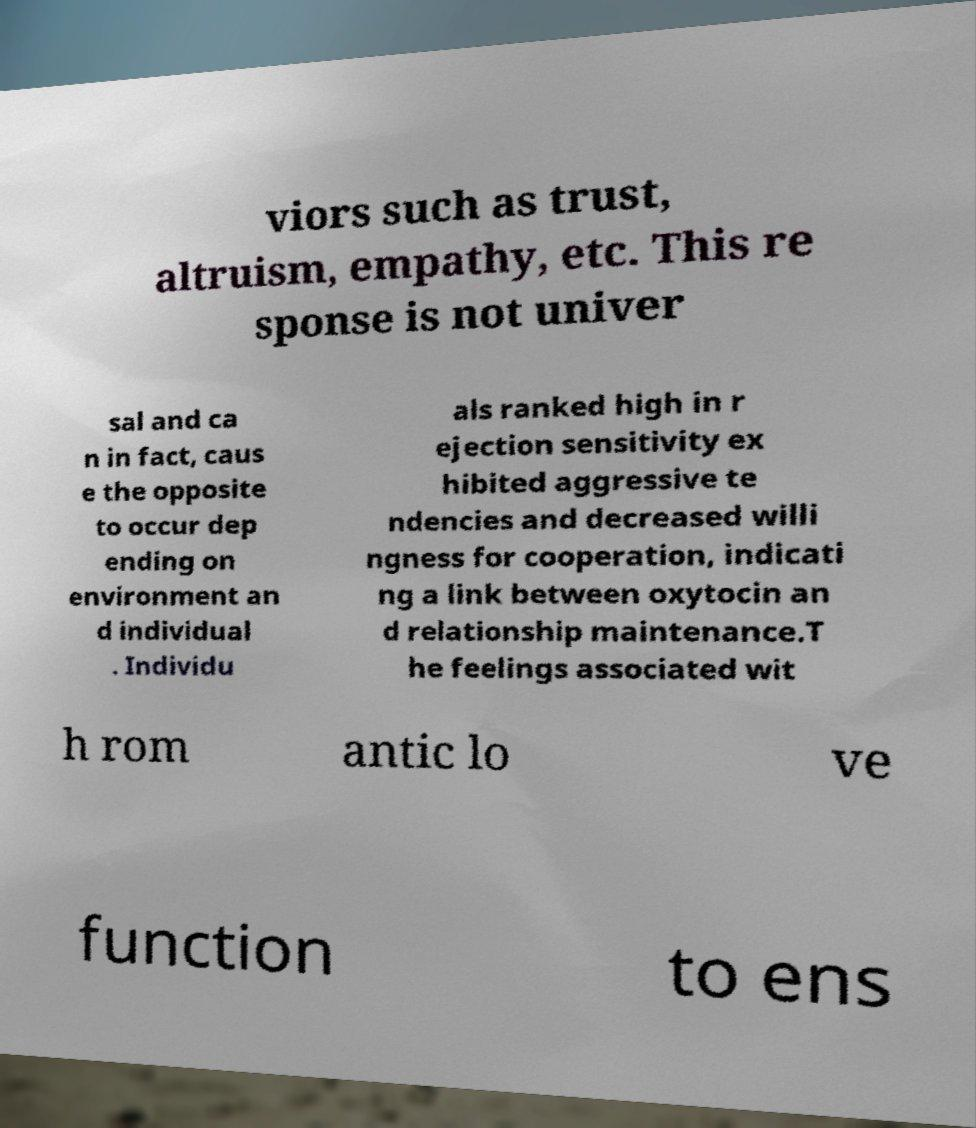Please identify and transcribe the text found in this image. viors such as trust, altruism, empathy, etc. This re sponse is not univer sal and ca n in fact, caus e the opposite to occur dep ending on environment an d individual . Individu als ranked high in r ejection sensitivity ex hibited aggressive te ndencies and decreased willi ngness for cooperation, indicati ng a link between oxytocin an d relationship maintenance.T he feelings associated wit h rom antic lo ve function to ens 